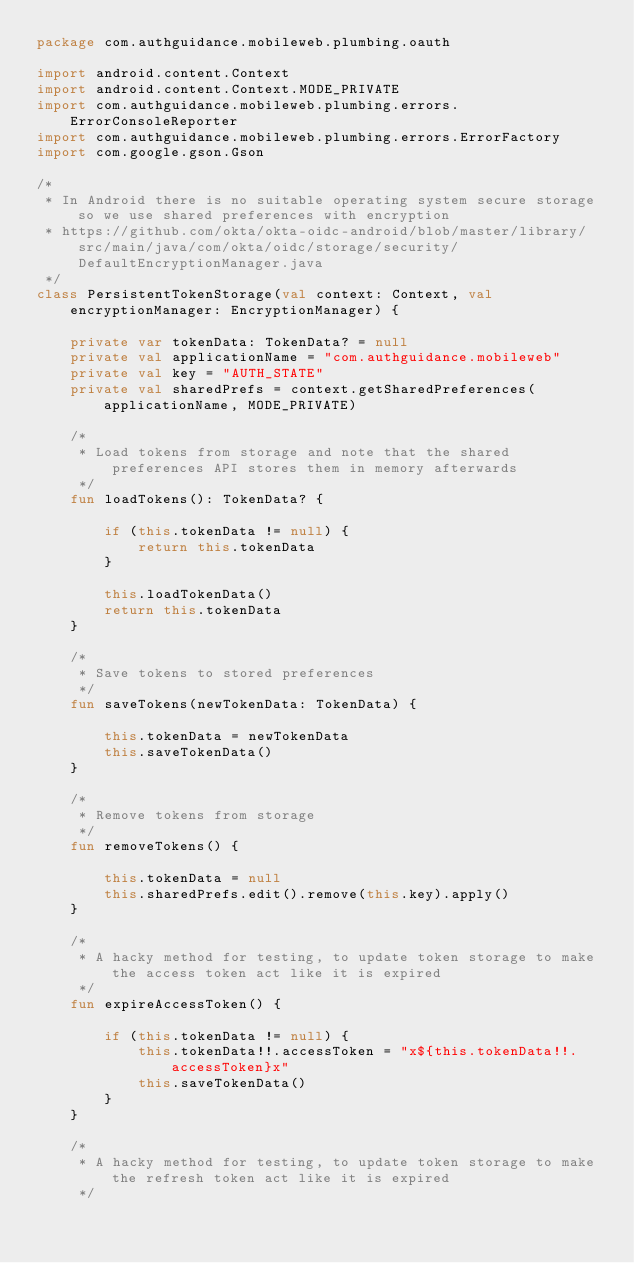Convert code to text. <code><loc_0><loc_0><loc_500><loc_500><_Kotlin_>package com.authguidance.mobileweb.plumbing.oauth

import android.content.Context
import android.content.Context.MODE_PRIVATE
import com.authguidance.mobileweb.plumbing.errors.ErrorConsoleReporter
import com.authguidance.mobileweb.plumbing.errors.ErrorFactory
import com.google.gson.Gson

/*
 * In Android there is no suitable operating system secure storage so we use shared preferences with encryption
 * https://github.com/okta/okta-oidc-android/blob/master/library/src/main/java/com/okta/oidc/storage/security/DefaultEncryptionManager.java
 */
class PersistentTokenStorage(val context: Context, val encryptionManager: EncryptionManager) {

    private var tokenData: TokenData? = null
    private val applicationName = "com.authguidance.mobileweb"
    private val key = "AUTH_STATE"
    private val sharedPrefs = context.getSharedPreferences(applicationName, MODE_PRIVATE)

    /*
     * Load tokens from storage and note that the shared preferences API stores them in memory afterwards
     */
    fun loadTokens(): TokenData? {

        if (this.tokenData != null) {
            return this.tokenData
        }

        this.loadTokenData()
        return this.tokenData
    }

    /*
     * Save tokens to stored preferences
     */
    fun saveTokens(newTokenData: TokenData) {

        this.tokenData = newTokenData
        this.saveTokenData()
    }

    /*
     * Remove tokens from storage
     */
    fun removeTokens() {

        this.tokenData = null
        this.sharedPrefs.edit().remove(this.key).apply()
    }

    /*
     * A hacky method for testing, to update token storage to make the access token act like it is expired
     */
    fun expireAccessToken() {

        if (this.tokenData != null) {
            this.tokenData!!.accessToken = "x${this.tokenData!!.accessToken}x"
            this.saveTokenData()
        }
    }

    /*
     * A hacky method for testing, to update token storage to make the refresh token act like it is expired
     */</code> 